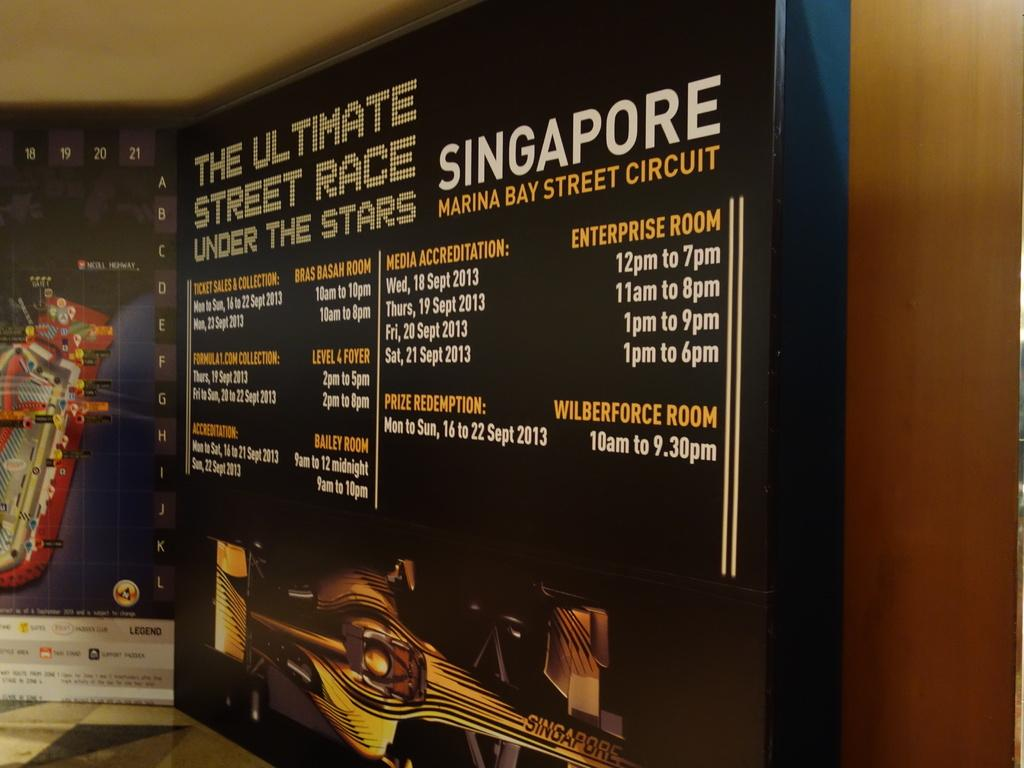Provide a one-sentence caption for the provided image. A sign displays an ad for the ultimate street race under the stars. 